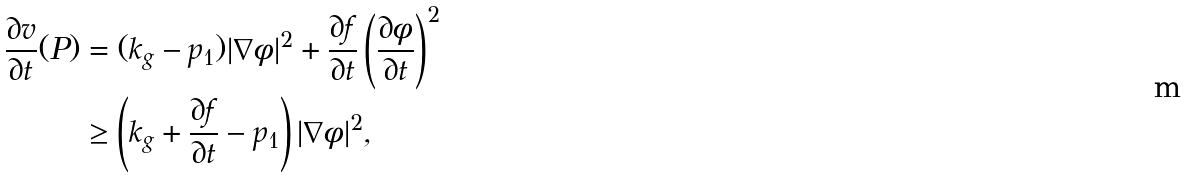<formula> <loc_0><loc_0><loc_500><loc_500>\frac { \partial v } { \partial t } ( P ) & = ( k _ { g } - p _ { 1 } ) | \nabla \phi | ^ { 2 } + \frac { \partial f } { \partial t } \left ( \frac { \partial \phi } { \partial t } \right ) ^ { 2 } \\ & \geq \left ( k _ { g } + \frac { \partial f } { \partial t } - p _ { 1 } \right ) | \nabla \phi | ^ { 2 } ,</formula> 